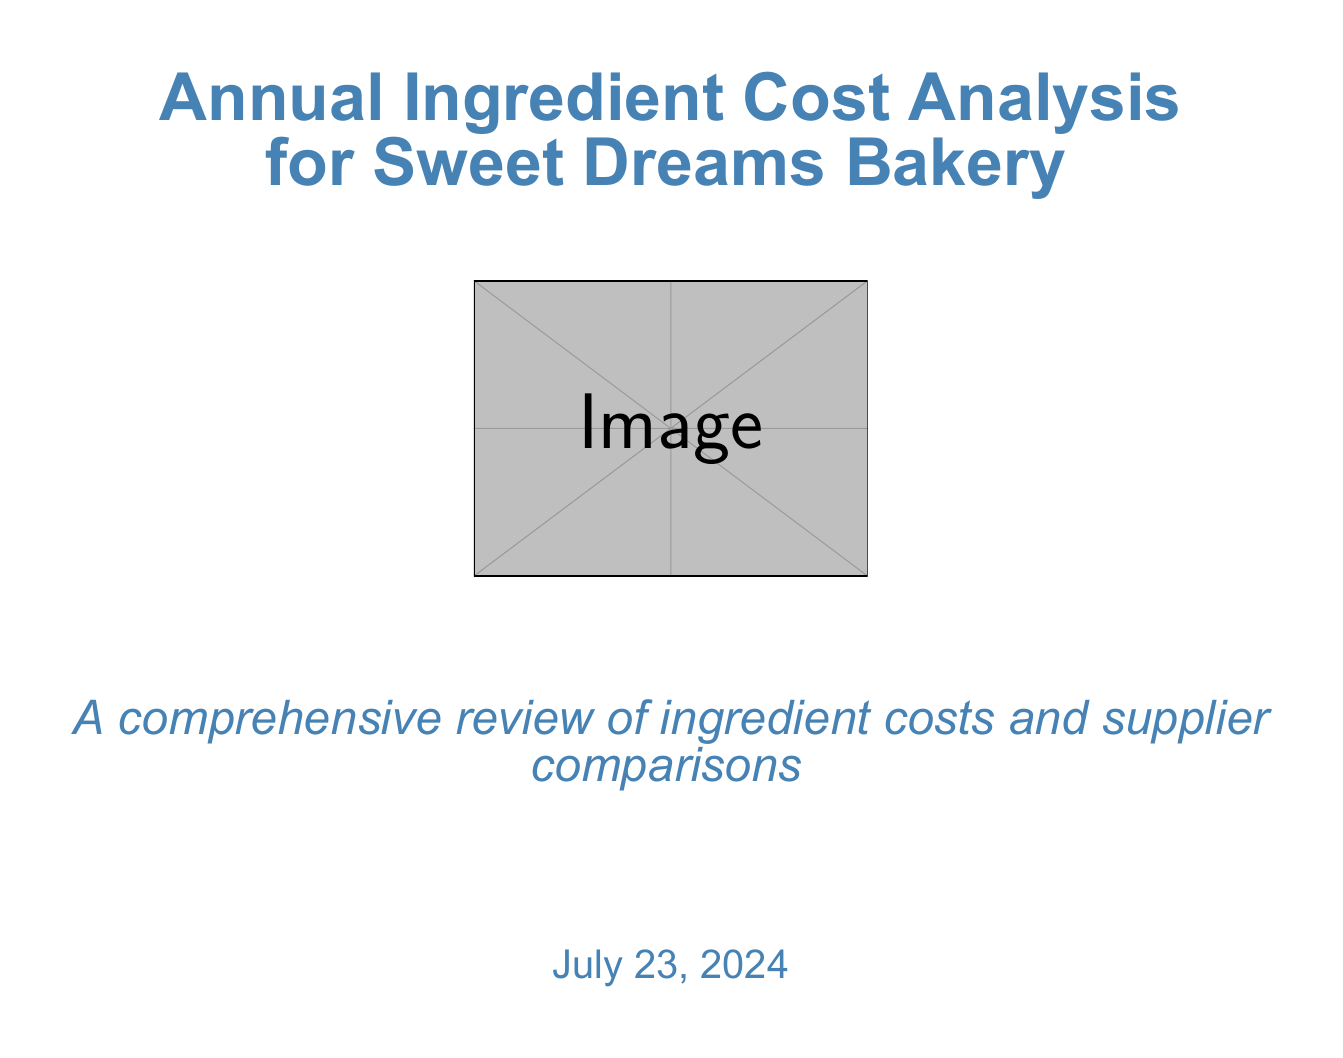what is the name of the bakery? The bakery is referred to as Sweet Dreams Bakery in the introduction section of the report.
Answer: Sweet Dreams Bakery when was Sweet Dreams Bakery established? The establishment year is mentioned in the introduction section of the report.
Answer: 2015 who is the current supplier for butter? The current supplier for butter is specified in the annual usage section of the report.
Answer: US Foods what is the price of sugar from US Foods? The price comparison for sugar from US Foods is listed in the price comparison section of the report.
Answer: $26.75 what are the potential annual savings by switching to Local Mill & Grains for flour? The document lists the potential savings from switching suppliers in the cost-saving opportunities section.
Answer: $156 how often does Sysco deliver? The delivery frequency for Sysco is stated in the suppliers section of the report.
Answer: Weekly which ingredient has a potential saving of $234 if switched to Sysco? The potential savings by switching suppliers can be found in the cost-saving opportunities section.
Answer: Butter what is one sustainability factor mentioned in the document? The sustainability factors are discussed in a specific section of the report, highlighting local sourcing and packaging.
Answer: Local sourcing what is the recommended timeline for implementing changes? The timeline for implementation is provided in the implementation plan section of the report.
Answer: Next quarter 